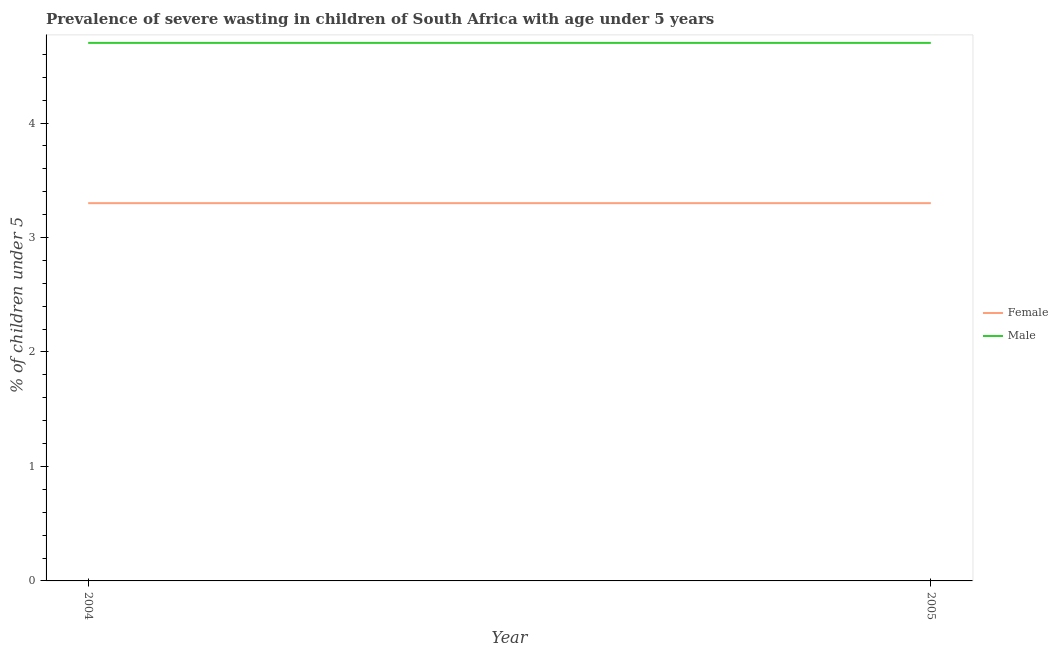Does the line corresponding to percentage of undernourished female children intersect with the line corresponding to percentage of undernourished male children?
Offer a terse response. No. What is the percentage of undernourished female children in 2004?
Offer a terse response. 3.3. Across all years, what is the maximum percentage of undernourished female children?
Make the answer very short. 3.3. Across all years, what is the minimum percentage of undernourished female children?
Offer a very short reply. 3.3. What is the total percentage of undernourished female children in the graph?
Keep it short and to the point. 6.6. What is the difference between the percentage of undernourished male children in 2005 and the percentage of undernourished female children in 2004?
Ensure brevity in your answer.  1.4. What is the average percentage of undernourished female children per year?
Your response must be concise. 3.3. In the year 2004, what is the difference between the percentage of undernourished male children and percentage of undernourished female children?
Your answer should be compact. 1.4. In how many years, is the percentage of undernourished female children greater than the average percentage of undernourished female children taken over all years?
Ensure brevity in your answer.  0. Does the percentage of undernourished male children monotonically increase over the years?
Provide a short and direct response. No. Is the percentage of undernourished male children strictly less than the percentage of undernourished female children over the years?
Offer a very short reply. No. How many lines are there?
Your response must be concise. 2. How many years are there in the graph?
Provide a short and direct response. 2. What is the difference between two consecutive major ticks on the Y-axis?
Ensure brevity in your answer.  1. Are the values on the major ticks of Y-axis written in scientific E-notation?
Make the answer very short. No. Does the graph contain any zero values?
Your response must be concise. No. How many legend labels are there?
Make the answer very short. 2. What is the title of the graph?
Make the answer very short. Prevalence of severe wasting in children of South Africa with age under 5 years. What is the label or title of the X-axis?
Make the answer very short. Year. What is the label or title of the Y-axis?
Your answer should be compact.  % of children under 5. What is the  % of children under 5 of Female in 2004?
Offer a terse response. 3.3. What is the  % of children under 5 in Male in 2004?
Offer a terse response. 4.7. What is the  % of children under 5 in Female in 2005?
Make the answer very short. 3.3. What is the  % of children under 5 of Male in 2005?
Provide a succinct answer. 4.7. Across all years, what is the maximum  % of children under 5 in Female?
Your answer should be very brief. 3.3. Across all years, what is the maximum  % of children under 5 in Male?
Offer a terse response. 4.7. Across all years, what is the minimum  % of children under 5 of Female?
Keep it short and to the point. 3.3. Across all years, what is the minimum  % of children under 5 in Male?
Offer a terse response. 4.7. What is the difference between the  % of children under 5 in Male in 2004 and that in 2005?
Your answer should be very brief. 0. What is the difference between the  % of children under 5 of Female in 2004 and the  % of children under 5 of Male in 2005?
Your answer should be very brief. -1.4. In the year 2004, what is the difference between the  % of children under 5 of Female and  % of children under 5 of Male?
Ensure brevity in your answer.  -1.4. What is the difference between the highest and the lowest  % of children under 5 in Male?
Make the answer very short. 0. 